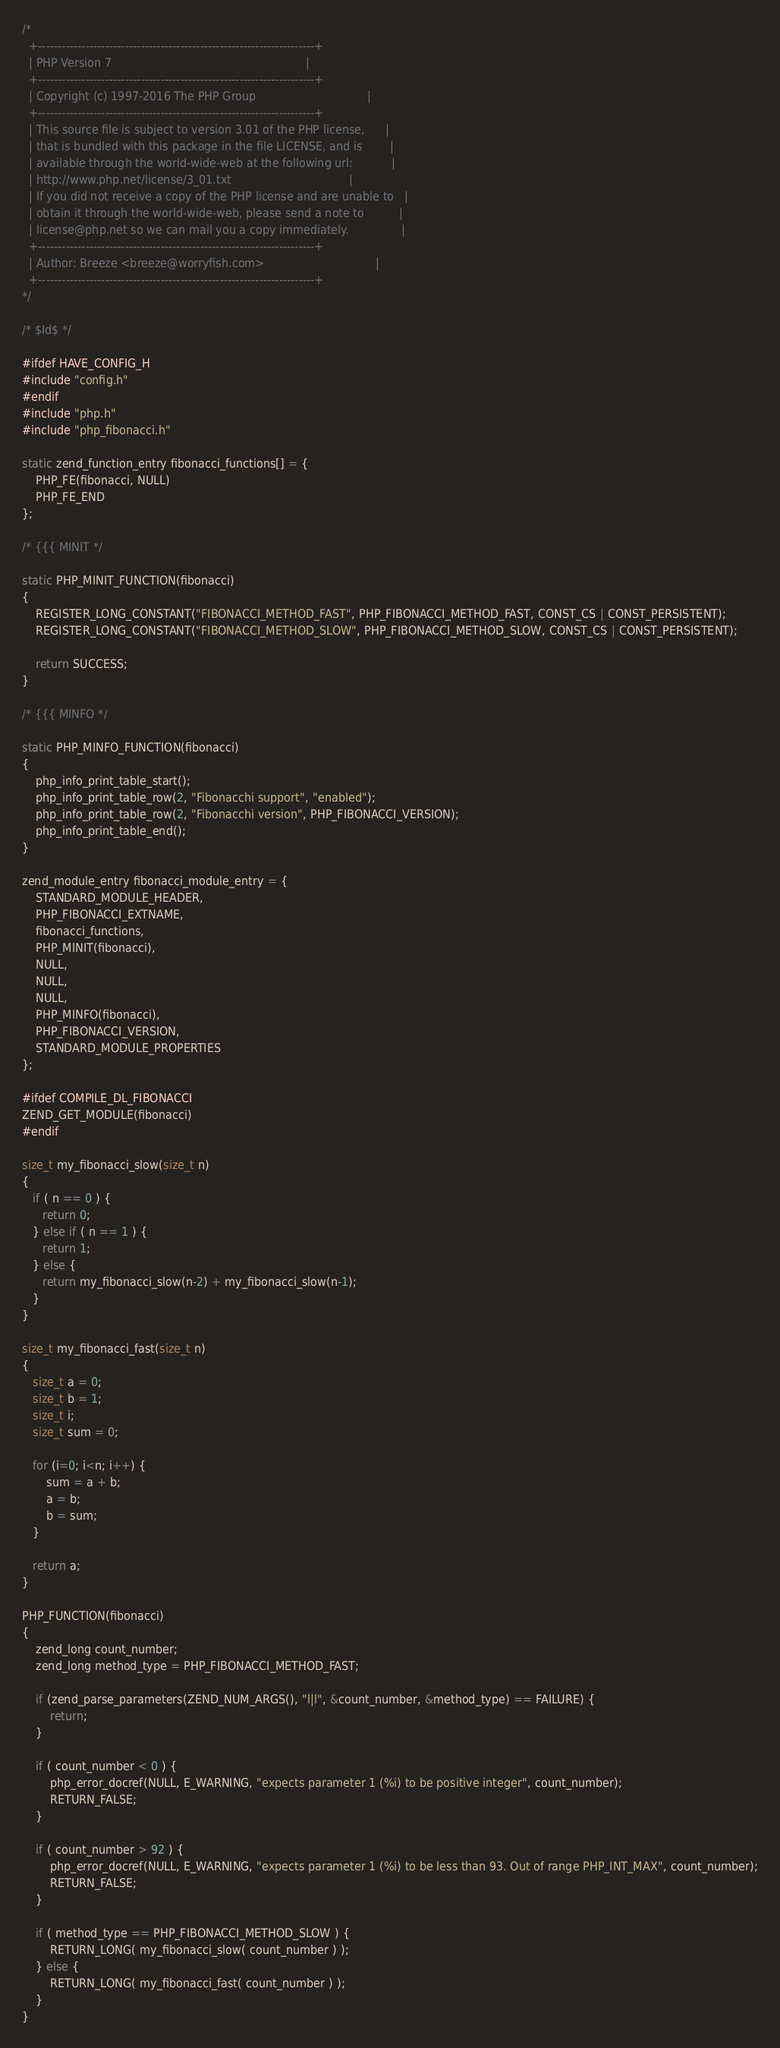Convert code to text. <code><loc_0><loc_0><loc_500><loc_500><_C_>/*
  +----------------------------------------------------------------------+
  | PHP Version 7                                                        |
  +----------------------------------------------------------------------+
  | Copyright (c) 1997-2016 The PHP Group                                |
  +----------------------------------------------------------------------+
  | This source file is subject to version 3.01 of the PHP license,      |
  | that is bundled with this package in the file LICENSE, and is        |
  | available through the world-wide-web at the following url:           |
  | http://www.php.net/license/3_01.txt                                  |
  | If you did not receive a copy of the PHP license and are unable to   |
  | obtain it through the world-wide-web, please send a note to          |
  | license@php.net so we can mail you a copy immediately.               |
  +----------------------------------------------------------------------+
  | Author: Breeze <breeze@worryfish.com>                                |
  +----------------------------------------------------------------------+
*/

/* $Id$ */

#ifdef HAVE_CONFIG_H
#include "config.h"
#endif
#include "php.h"
#include "php_fibonacci.h"

static zend_function_entry fibonacci_functions[] = {
    PHP_FE(fibonacci, NULL)
    PHP_FE_END
};

/* {{{ MINIT */

static PHP_MINIT_FUNCTION(fibonacci)
{
    REGISTER_LONG_CONSTANT("FIBONACCI_METHOD_FAST", PHP_FIBONACCI_METHOD_FAST, CONST_CS | CONST_PERSISTENT);
    REGISTER_LONG_CONSTANT("FIBONACCI_METHOD_SLOW", PHP_FIBONACCI_METHOD_SLOW, CONST_CS | CONST_PERSISTENT);
    
    return SUCCESS;
}

/* {{{ MINFO */

static PHP_MINFO_FUNCTION(fibonacci)
{
    php_info_print_table_start();
    php_info_print_table_row(2, "Fibonacchi support", "enabled");
    php_info_print_table_row(2, "Fibonacchi version", PHP_FIBONACCI_VERSION);
    php_info_print_table_end();
}

zend_module_entry fibonacci_module_entry = {
    STANDARD_MODULE_HEADER,
    PHP_FIBONACCI_EXTNAME,
    fibonacci_functions,
    PHP_MINIT(fibonacci),
    NULL,
    NULL,
    NULL,
    PHP_MINFO(fibonacci),
    PHP_FIBONACCI_VERSION,
    STANDARD_MODULE_PROPERTIES
};

#ifdef COMPILE_DL_FIBONACCI
ZEND_GET_MODULE(fibonacci)
#endif

size_t my_fibonacci_slow(size_t n)
{
   if ( n == 0 ) {
      return 0;
   } else if ( n == 1 ) {
      return 1;
   } else {
      return my_fibonacci_slow(n-2) + my_fibonacci_slow(n-1);
   }
} 

size_t my_fibonacci_fast(size_t n)
{
   size_t a = 0;
   size_t b = 1;
   size_t i;
   size_t sum = 0;
   
   for (i=0; i<n; i++) {
       sum = a + b;
       a = b;
       b = sum;
   }
   
   return a;
} 

PHP_FUNCTION(fibonacci)
{
    zend_long count_number;
    zend_long method_type = PHP_FIBONACCI_METHOD_FAST;
    
    if (zend_parse_parameters(ZEND_NUM_ARGS(), "l|l", &count_number, &method_type) == FAILURE) {
        return;
    }
    
    if ( count_number < 0 ) {
        php_error_docref(NULL, E_WARNING, "expects parameter 1 (%i) to be positive integer", count_number);
        RETURN_FALSE;
    }
    
    if ( count_number > 92 ) {
        php_error_docref(NULL, E_WARNING, "expects parameter 1 (%i) to be less than 93. Out of range PHP_INT_MAX", count_number);
        RETURN_FALSE;
    }
    
    if ( method_type == PHP_FIBONACCI_METHOD_SLOW ) {
        RETURN_LONG( my_fibonacci_slow( count_number ) );
    } else {
        RETURN_LONG( my_fibonacci_fast( count_number ) );
    }
}
</code> 